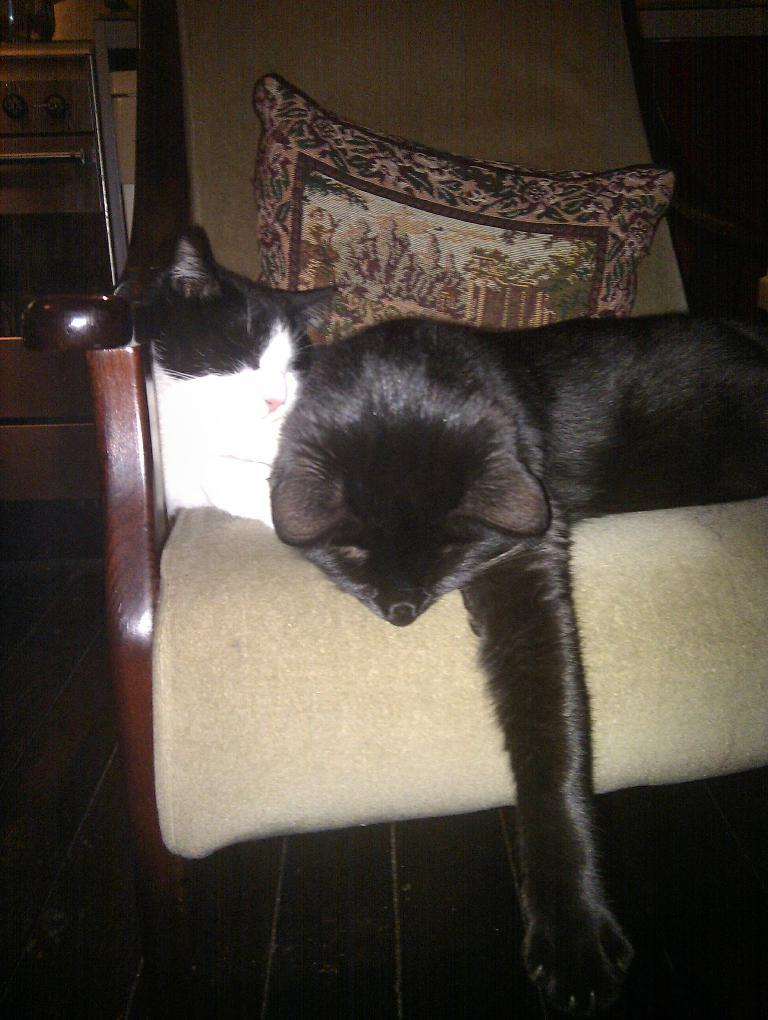How many cats are in the image? There are two cats in the image. What are the cats doing in the image? The cats are sleeping in the image. Where are the cats located in the image? The cats are in a chair in the image. What is present behind the cats in the image? There is a pillow behind the cats in the image. What type of quilt is covering the cats in the image? There is no quilt present in the image; the cats are sleeping on a chair with a pillow behind them. Can you see a veil on the cats in the image? There is no veil present on the cats in the image; they are simply sleeping. 